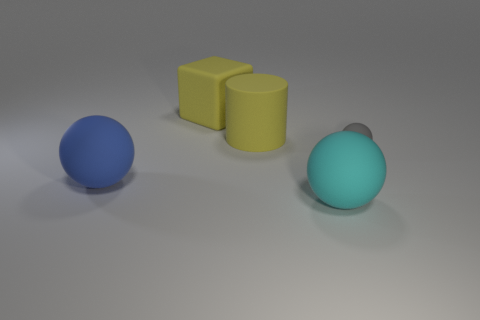Subtract all large rubber balls. How many balls are left? 1 Subtract all blue balls. How many balls are left? 2 Subtract all cylinders. How many objects are left? 4 Subtract 1 cylinders. How many cylinders are left? 0 Add 2 big cyan rubber cylinders. How many objects exist? 7 Subtract 0 purple cylinders. How many objects are left? 5 Subtract all brown balls. Subtract all green cylinders. How many balls are left? 3 Subtract all big yellow cubes. Subtract all cylinders. How many objects are left? 3 Add 3 large cubes. How many large cubes are left? 4 Add 2 blue matte balls. How many blue matte balls exist? 3 